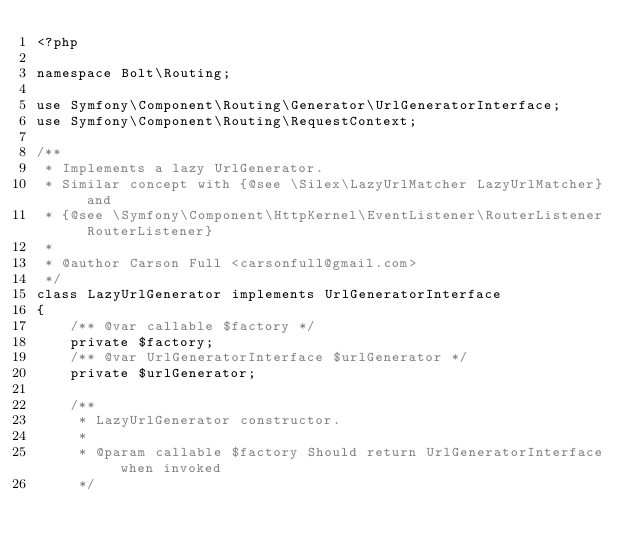<code> <loc_0><loc_0><loc_500><loc_500><_PHP_><?php

namespace Bolt\Routing;

use Symfony\Component\Routing\Generator\UrlGeneratorInterface;
use Symfony\Component\Routing\RequestContext;

/**
 * Implements a lazy UrlGenerator.
 * Similar concept with {@see \Silex\LazyUrlMatcher LazyUrlMatcher} and
 * {@see \Symfony\Component\HttpKernel\EventListener\RouterListener RouterListener}
 *
 * @author Carson Full <carsonfull@gmail.com>
 */
class LazyUrlGenerator implements UrlGeneratorInterface
{
    /** @var callable $factory */
    private $factory;
    /** @var UrlGeneratorInterface $urlGenerator */
    private $urlGenerator;

    /**
     * LazyUrlGenerator constructor.
     *
     * @param callable $factory Should return UrlGeneratorInterface when invoked
     */</code> 